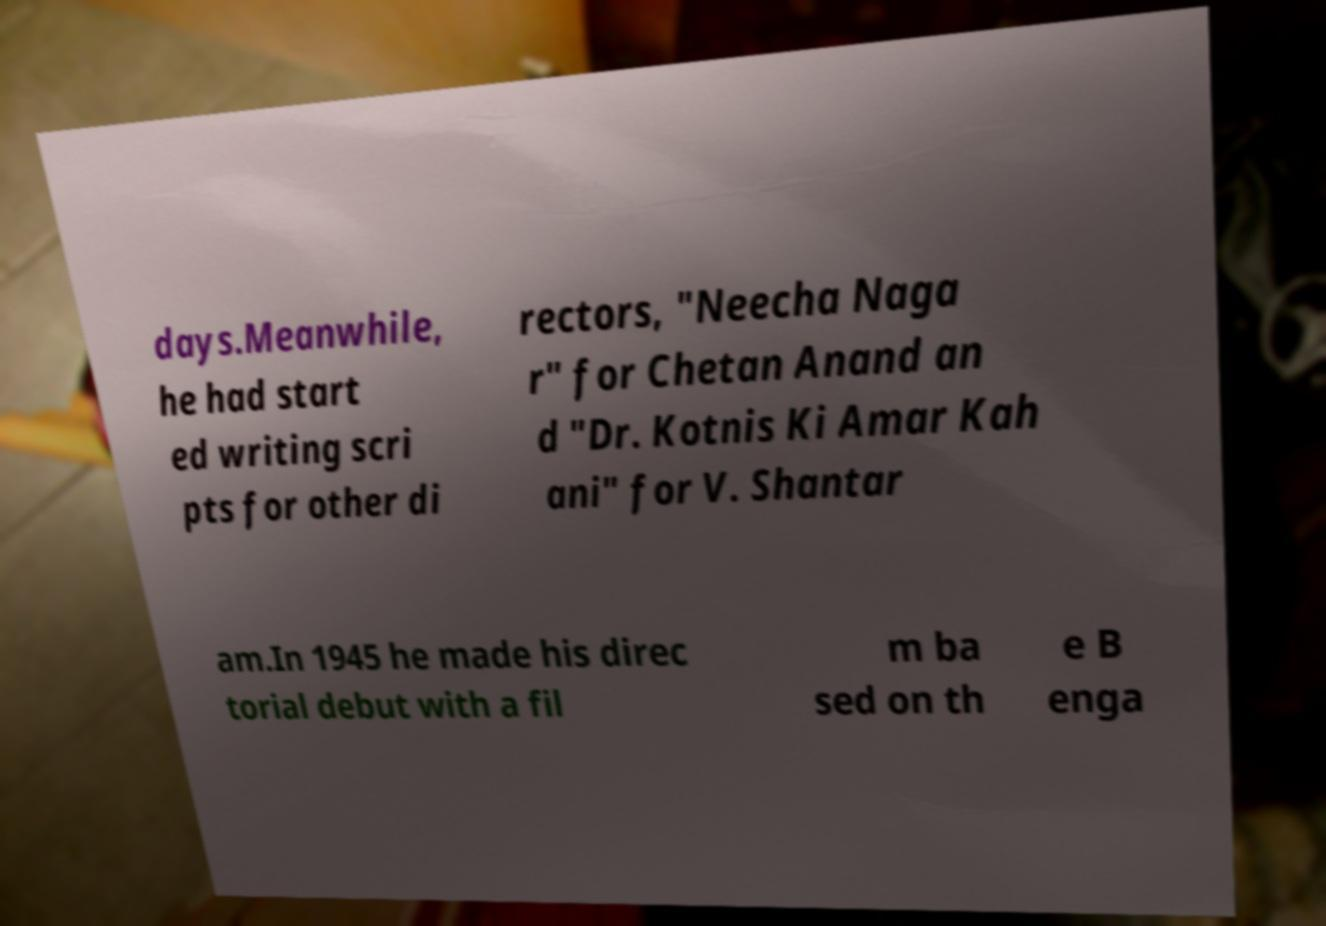I need the written content from this picture converted into text. Can you do that? days.Meanwhile, he had start ed writing scri pts for other di rectors, "Neecha Naga r" for Chetan Anand an d "Dr. Kotnis Ki Amar Kah ani" for V. Shantar am.In 1945 he made his direc torial debut with a fil m ba sed on th e B enga 